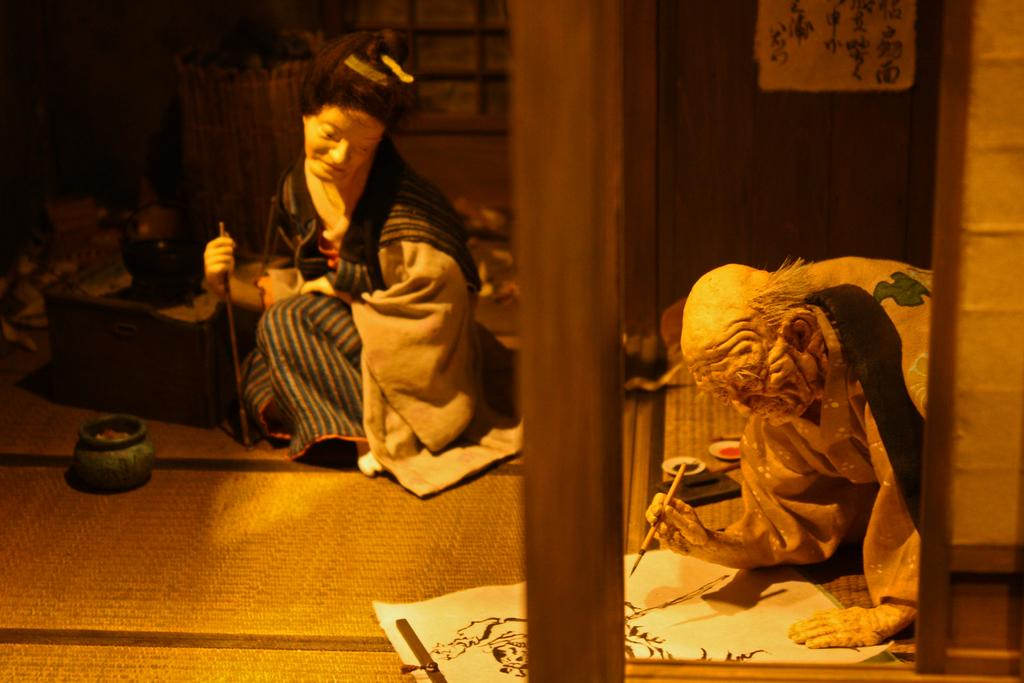How many statues are present in the image? There are two statues in the image. What is located on the left side of the image? There is a pot on the left side of the image. What can be found at the bottom of the image? There is a paper with a painting at the bottom of the image. What type of whip is being used by the statues in the image? There are no whips present in the image, and the statues are not using any tools or objects. 